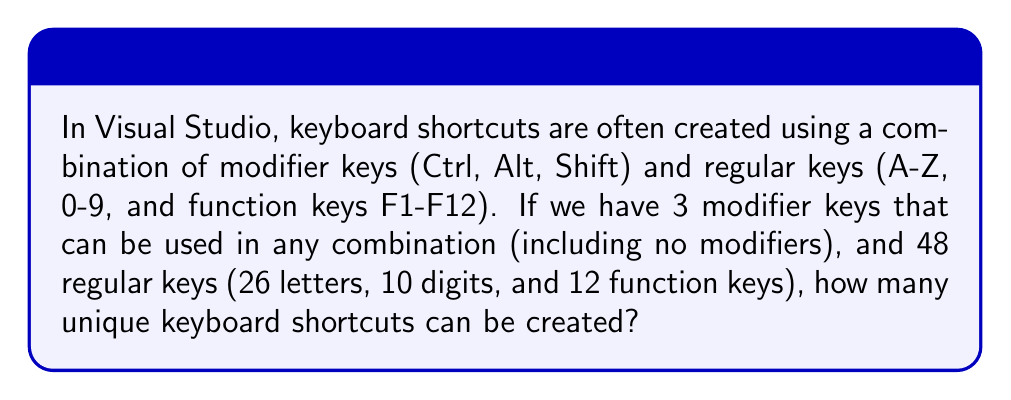Help me with this question. Let's approach this step-by-step:

1) First, let's consider the modifier keys:
   - We have 3 modifier keys (Ctrl, Alt, Shift)
   - Each modifier key can be either pressed or not pressed
   - This gives us $2^3 = 8$ possible combinations of modifier keys (including no modifiers)

2) Now, for the regular keys:
   - We have 48 regular keys (26 letters + 10 digits + 12 function keys)
   - Each shortcut must include exactly one regular key

3) To calculate the total number of unique shortcuts:
   - For each combination of modifier keys, we can choose any of the 48 regular keys
   - This means we multiply the number of modifier combinations by the number of regular keys

4) Therefore, the total number of unique shortcuts is:

   $$ \text{Total shortcuts} = \text{Modifier combinations} \times \text{Regular keys} $$
   $$ = 2^3 \times 48 $$
   $$ = 8 \times 48 $$
   $$ = 384 $$

Thus, there are 384 possible unique keyboard shortcuts in Visual Studio given this set of keys.
Answer: 384 